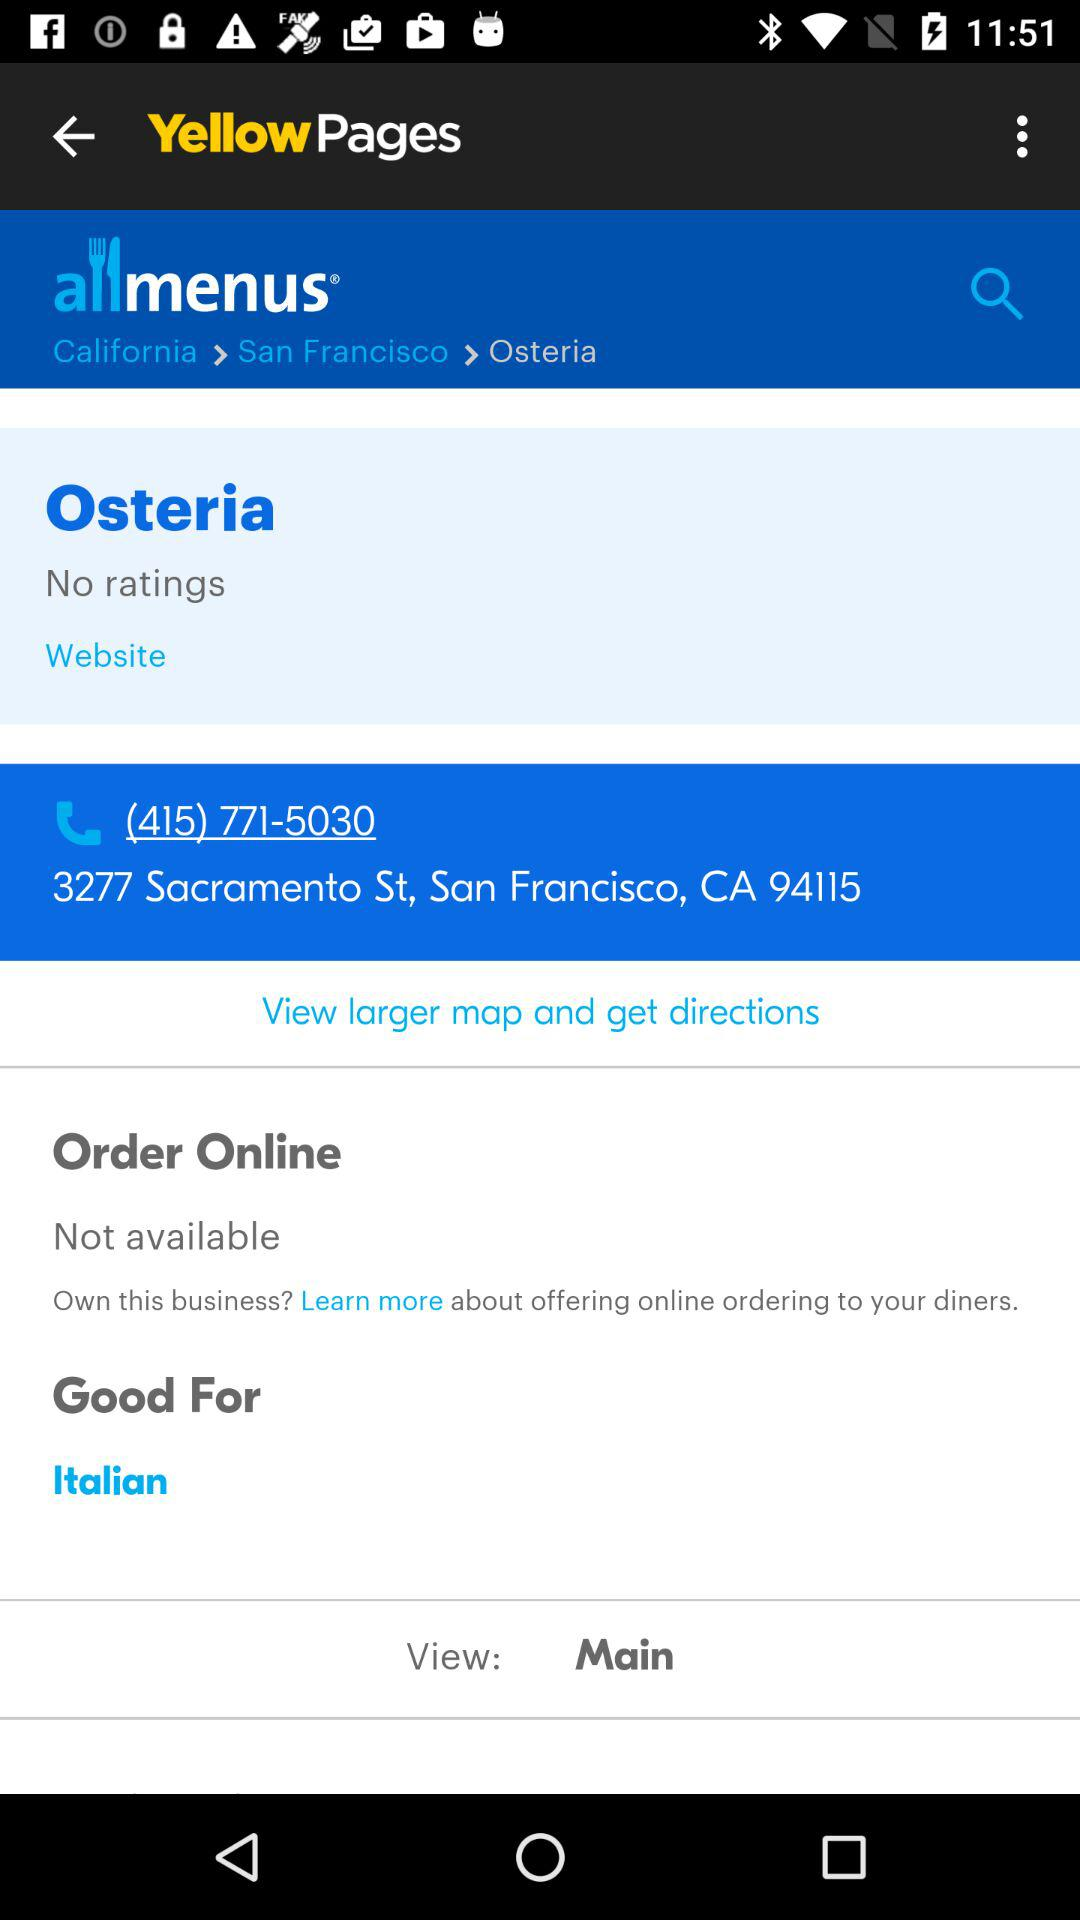What is the contact number? The contact number is (415) 771-5030. 